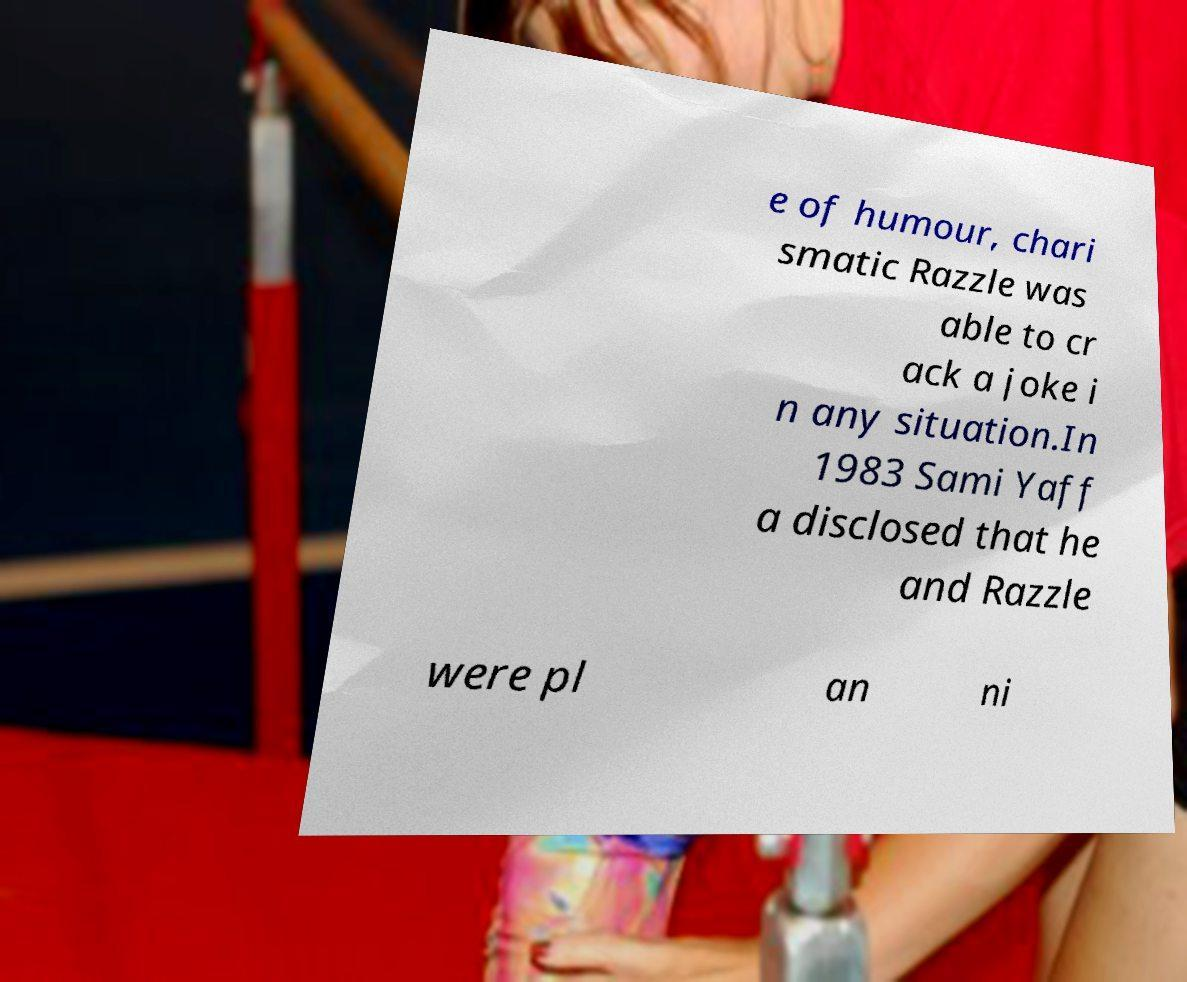What messages or text are displayed in this image? I need them in a readable, typed format. e of humour, chari smatic Razzle was able to cr ack a joke i n any situation.In 1983 Sami Yaff a disclosed that he and Razzle were pl an ni 